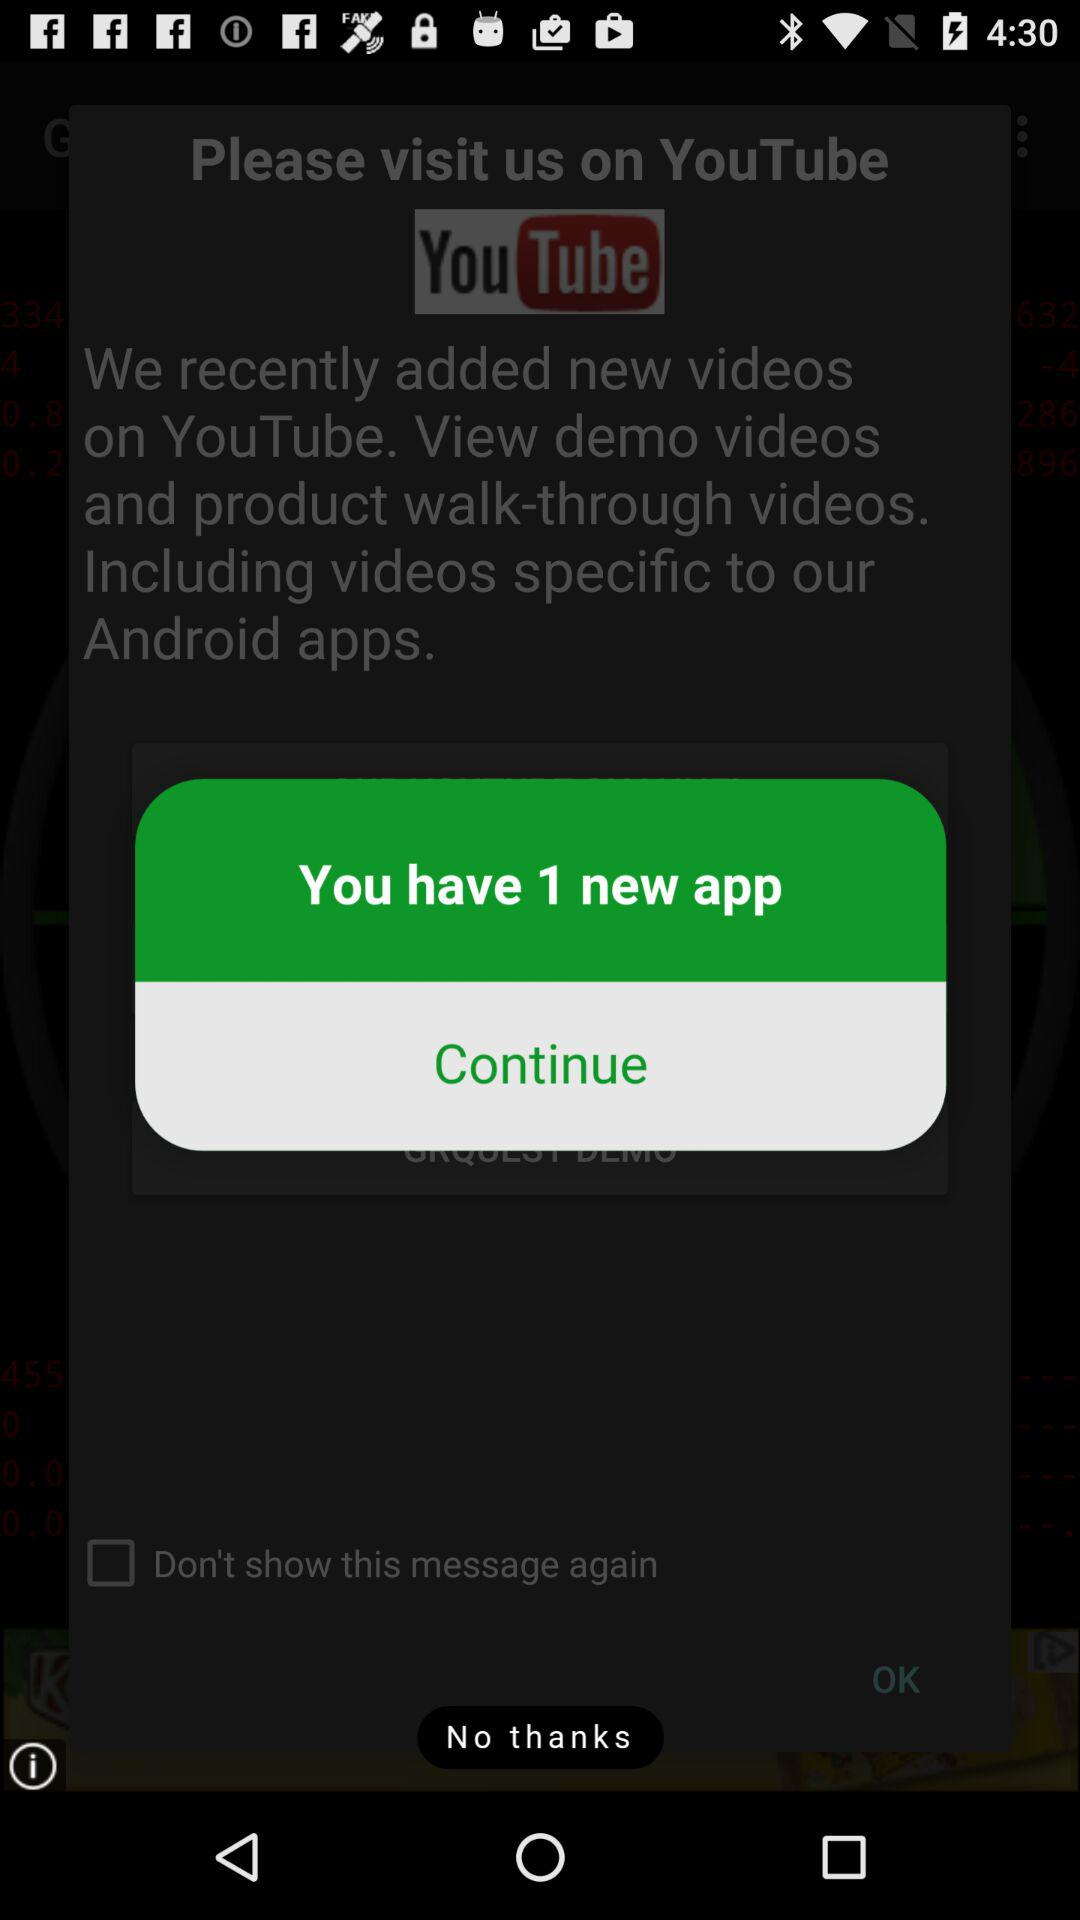How many new applications are there? There is 1 new application. 